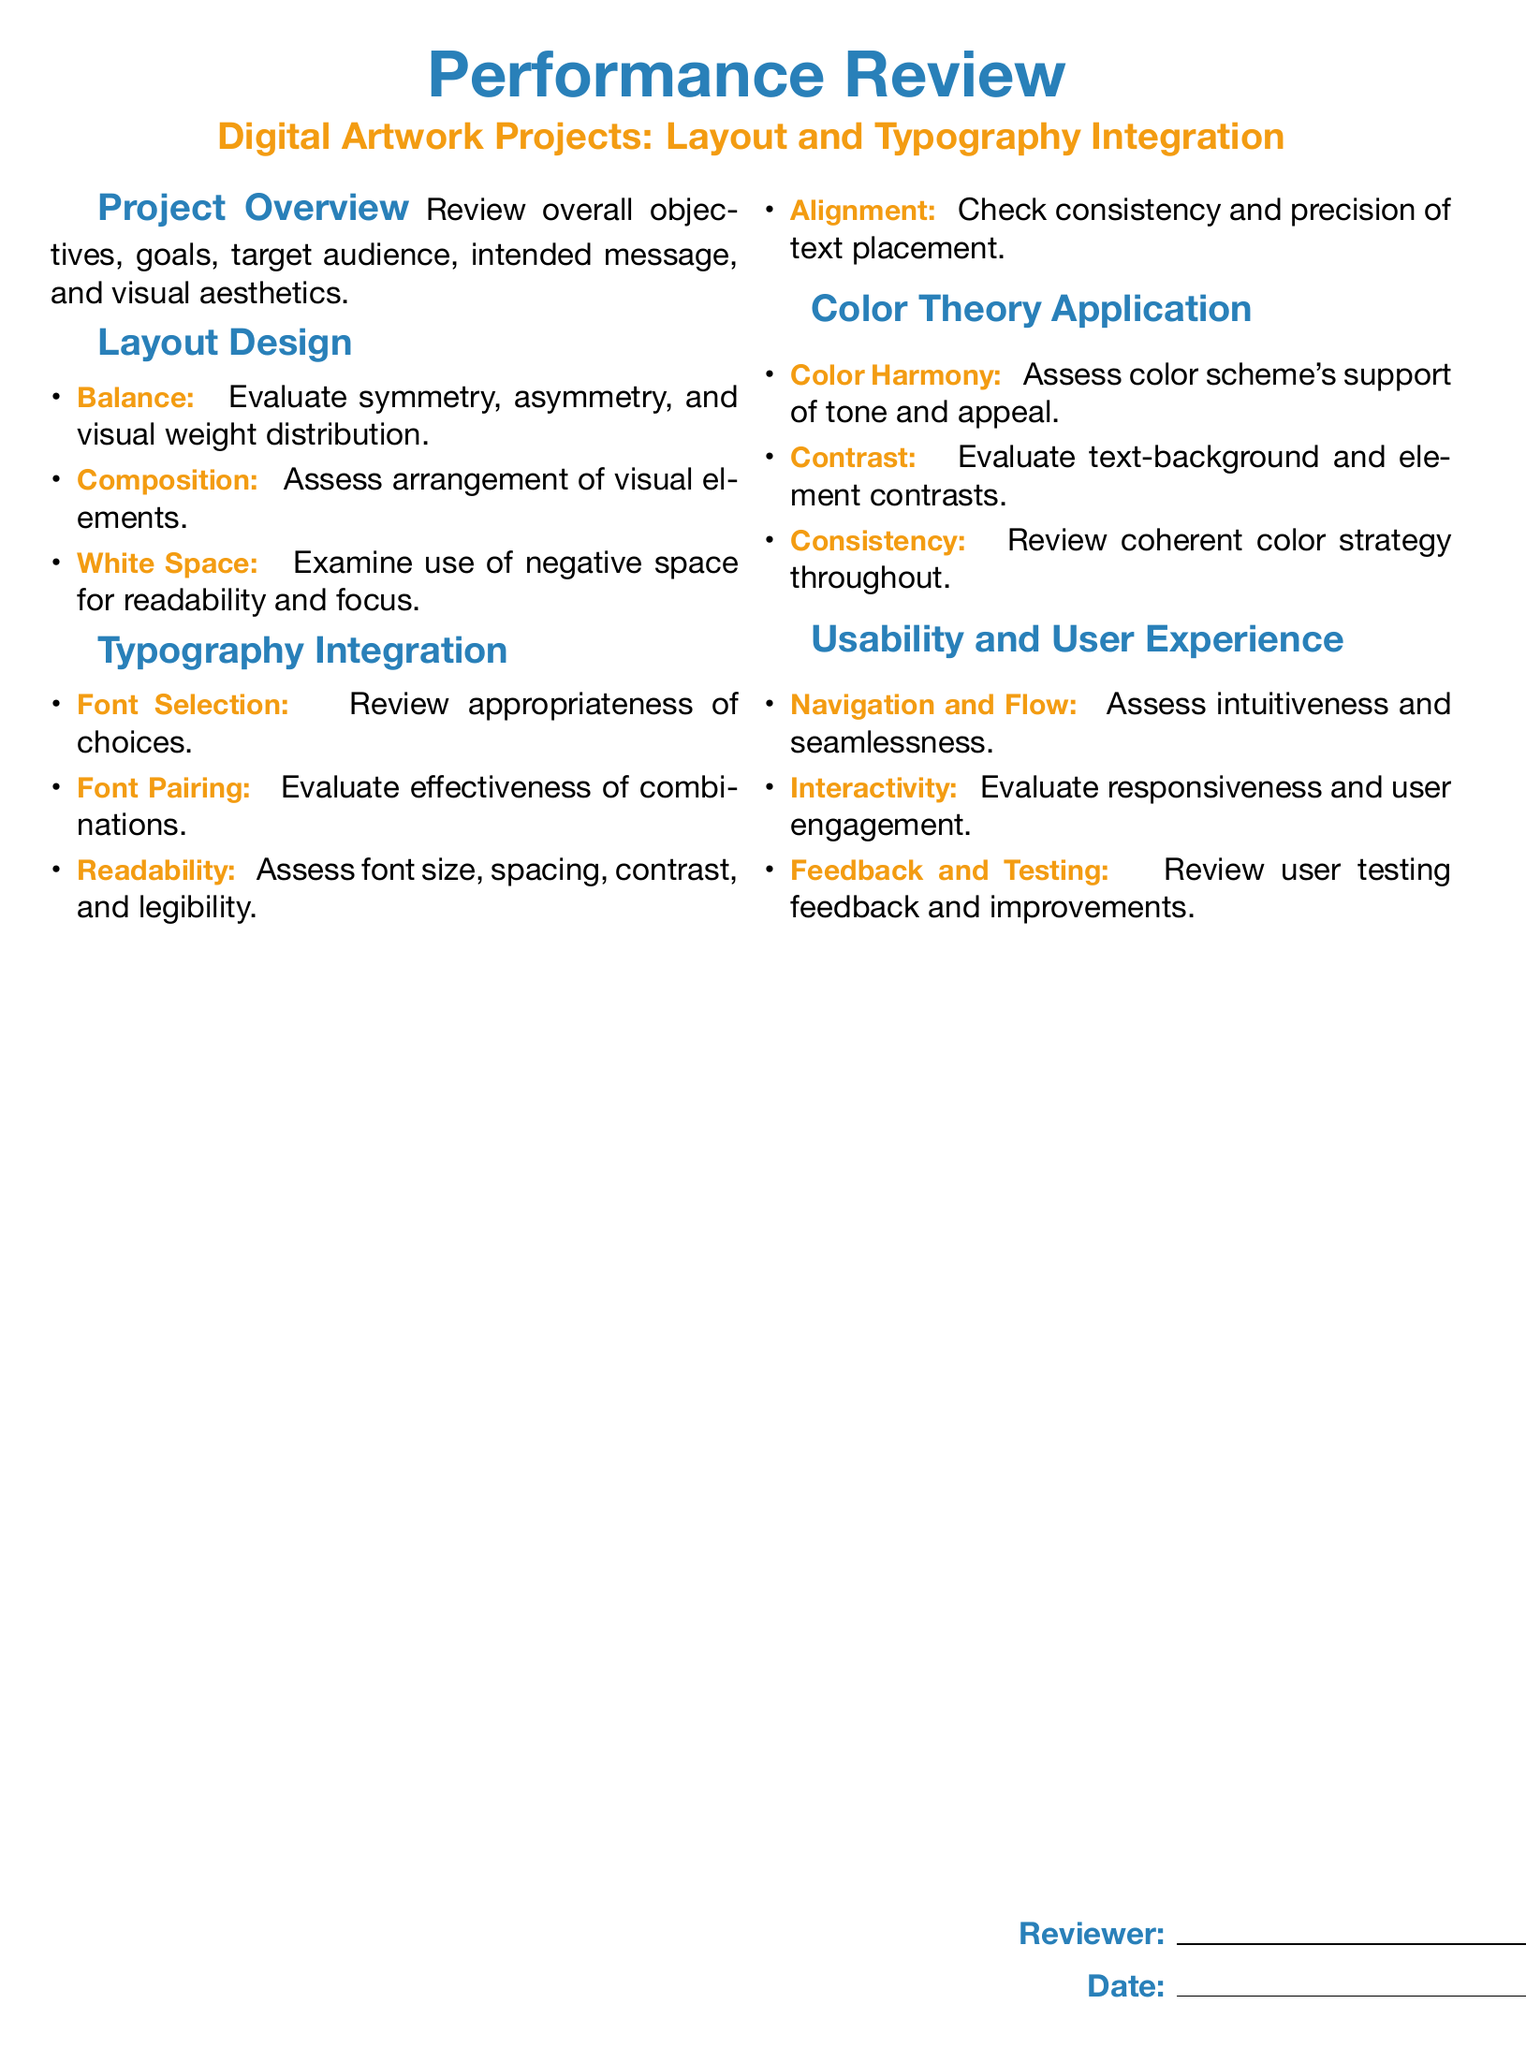What is the main title of the document? The main title is highlighted at the top of the document, presenting the purpose of the form clearly.
Answer: Performance Review What is the subtitle related to the specific projects? The subtitle provides context on the type of projects being reviewed, indicating the focus area of the appraisal.
Answer: Digital Artwork Projects: Layout and Typography Integration What are the three aspects evaluated under 'Layout Design'? This question looks for key components listed in the 'Layout Design' section of the document, essential for assessment.
Answer: Balance, Composition, White Space What color is defined as 'maincolor'? This question seeks to identify the specific RGB value associated with the designated main color used throughout the document.
Answer: 41,128,185 What does the 'Typography Integration' section assess? This question asks for a summary of the areas evaluated within the typography section, essential for understanding the form's focus on text.
Answer: Font Selection, Font Pairing, Readability, Alignment How is 'Color Harmony' related to the project? This question requires connecting the concept of color harmony to the visual appeal and emotional tone of the artwork.
Answer: Support of tone and appeal Who is required to fill out the reviewer section? This question identifies the intended individual responsible for completing the review document, which provides accountability.
Answer: Reviewer What month is indicated for the date of the review? The date of the review is significant for documentation purposes, and this question seeks to specify that aspect.
Answer: Date 